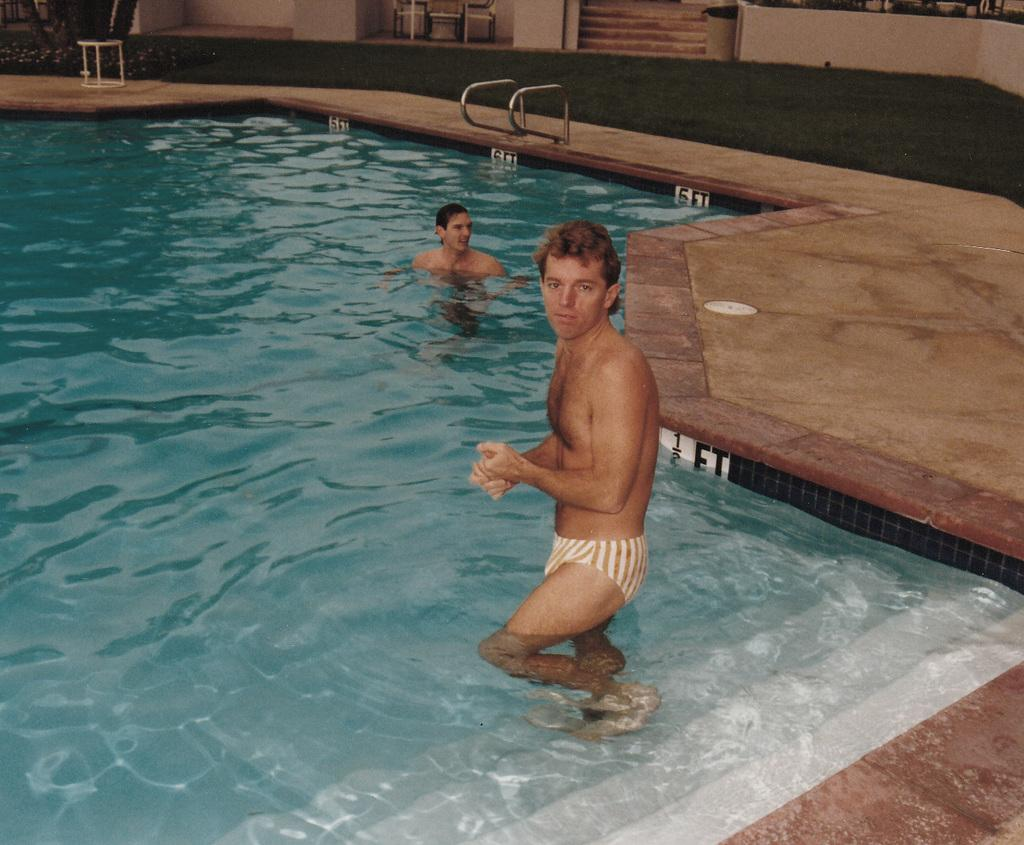What is the main feature of the image? There is a swimming pool in the image. How many people are in the image? There are two persons in the image. What are the actions of the two persons in the image? One person is standing on the stairs of the swimming pool, while the other person is swimming in the pool. What can be seen at the top of the image? There are chairs and a wall visible at the top of the image. What type of whistle can be heard in the image? There is no whistle present in the image, and therefore no sound can be heard. What kind of toy is being used by the person swimming in the image? There is no toy visible in the image; the person swimming is not using any toy. 